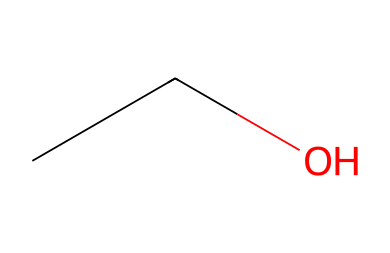What is the name of this chemical? The SMILES representation CCCO corresponds to ethanol, which is commonly known as ethyl alcohol.
Answer: ethanol How many carbon atoms are present in this molecule? By examining the SMILES notation "CCO", we see that there are two 'C' characters indicating two carbon atoms.
Answer: 2 What is the functional group present in ethanol? The "O" in the SMILES representation indicates an alcohol functional group, specifically a hydroxyl (-OH) group.
Answer: hydroxyl What is the total number of hydrogen atoms in this compound? The structure of ethanol indicated by C2H6O suggests that there are six hydrogen atoms attached to the two carbon atoms, balanced with one oxygen atom.
Answer: 6 What denotes that ethanol is a saturated hydrocarbon? Ethanol has only single bonds between the carbon and hydrogen atoms (indicated by the absence of double or triple bonds in the SMILES), classifying it as a saturated hydrocarbon.
Answer: single bonds Is ethanol a primary, secondary, or tertiary alcohol? Ethanol has the hydroxyl group attached to a carbon atom that is bonded to one other carbon atom, making it a primary alcohol.
Answer: primary 